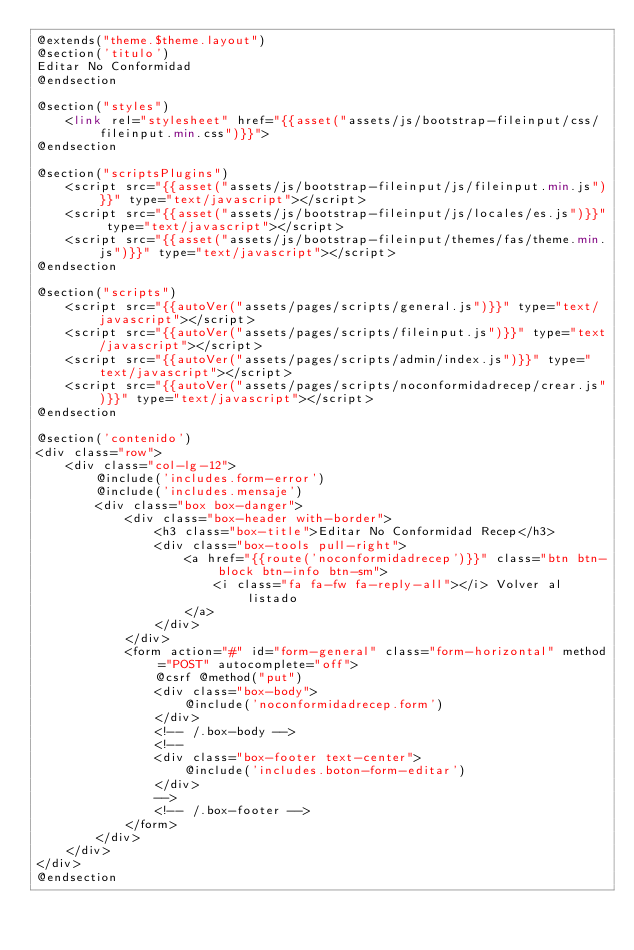<code> <loc_0><loc_0><loc_500><loc_500><_PHP_>@extends("theme.$theme.layout")
@section('titulo')
Editar No Conformidad
@endsection

@section("styles")
    <link rel="stylesheet" href="{{asset("assets/js/bootstrap-fileinput/css/fileinput.min.css")}}">
@endsection

@section("scriptsPlugins")
    <script src="{{asset("assets/js/bootstrap-fileinput/js/fileinput.min.js")}}" type="text/javascript"></script>
    <script src="{{asset("assets/js/bootstrap-fileinput/js/locales/es.js")}}" type="text/javascript"></script>
    <script src="{{asset("assets/js/bootstrap-fileinput/themes/fas/theme.min.js")}}" type="text/javascript"></script>
@endsection

@section("scripts")
    <script src="{{autoVer("assets/pages/scripts/general.js")}}" type="text/javascript"></script>
    <script src="{{autoVer("assets/pages/scripts/fileinput.js")}}" type="text/javascript"></script>
    <script src="{{autoVer("assets/pages/scripts/admin/index.js")}}" type="text/javascript"></script>
    <script src="{{autoVer("assets/pages/scripts/noconformidadrecep/crear.js")}}" type="text/javascript"></script>
@endsection

@section('contenido')
<div class="row">
    <div class="col-lg-12">
        @include('includes.form-error')
        @include('includes.mensaje')
        <div class="box box-danger">
            <div class="box-header with-border">
                <h3 class="box-title">Editar No Conformidad Recep</h3>
                <div class="box-tools pull-right">
                    <a href="{{route('noconformidadrecep')}}" class="btn btn-block btn-info btn-sm">
                        <i class="fa fa-fw fa-reply-all"></i> Volver al listado
                    </a>
                </div>
            </div>
            <form action="#" id="form-general" class="form-horizontal" method="POST" autocomplete="off">
                @csrf @method("put")
                <div class="box-body">
                    @include('noconformidadrecep.form')
                </div>
                <!-- /.box-body -->
                <!--
                <div class="box-footer text-center">
                    @include('includes.boton-form-editar')
                </div>
                -->
                <!-- /.box-footer -->
            </form>
        </div>
    </div>
</div>
@endsection</code> 